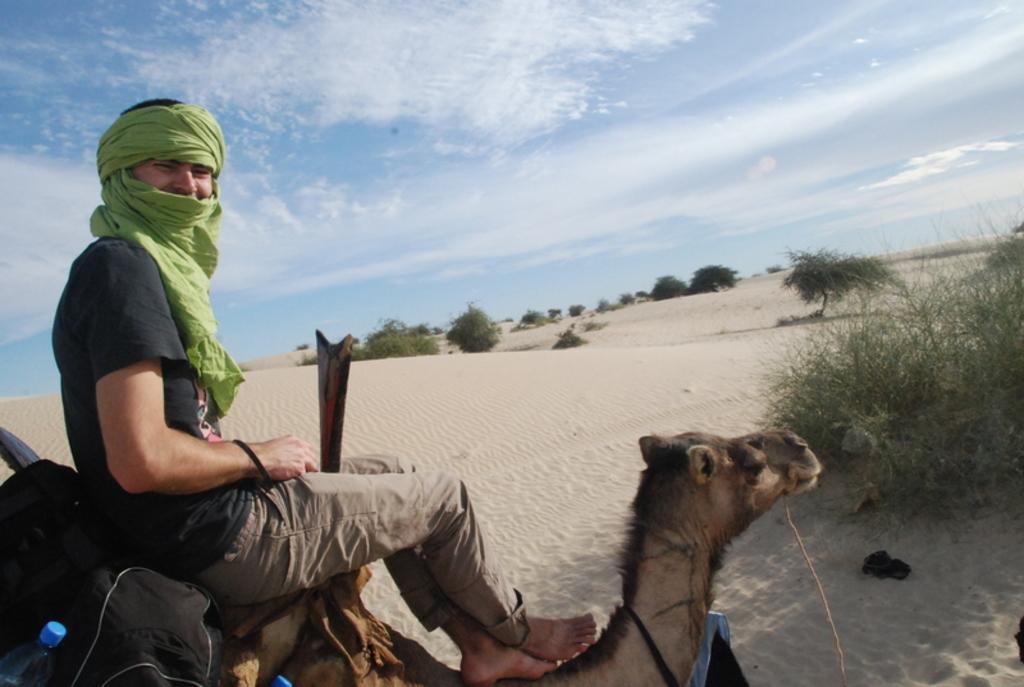Describe this image in one or two sentences. In this image there is one person is riding on the horse on the left side of this image and there is a desert area in middle of this image. There are some trees as we can see in middle of this image and on the right side of this image as well. there is a sky on the top of this image. 